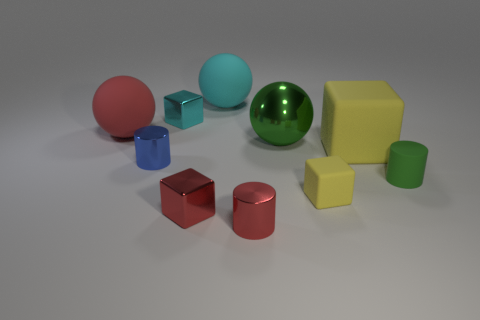Are the cyan block and the large green sphere made of the same material?
Provide a succinct answer. Yes. What number of cylinders are either small purple metal objects or green metallic things?
Make the answer very short. 0. What is the color of the large ball that is made of the same material as the tiny blue thing?
Keep it short and to the point. Green. Is the number of matte cylinders less than the number of big purple blocks?
Your response must be concise. No. There is a green thing that is to the left of the green matte cylinder; does it have the same shape as the cyan object that is on the right side of the cyan block?
Keep it short and to the point. Yes. What number of objects are big metal cubes or large matte spheres?
Offer a very short reply. 2. What color is the rubber cylinder that is the same size as the cyan metal cube?
Offer a very short reply. Green. What number of shiny things are on the left side of the red object to the right of the big cyan rubber ball?
Offer a terse response. 3. What number of objects are on the right side of the red metallic cube and in front of the blue thing?
Give a very brief answer. 3. How many things are red objects in front of the tiny matte block or matte objects right of the small yellow object?
Your answer should be compact. 4. 